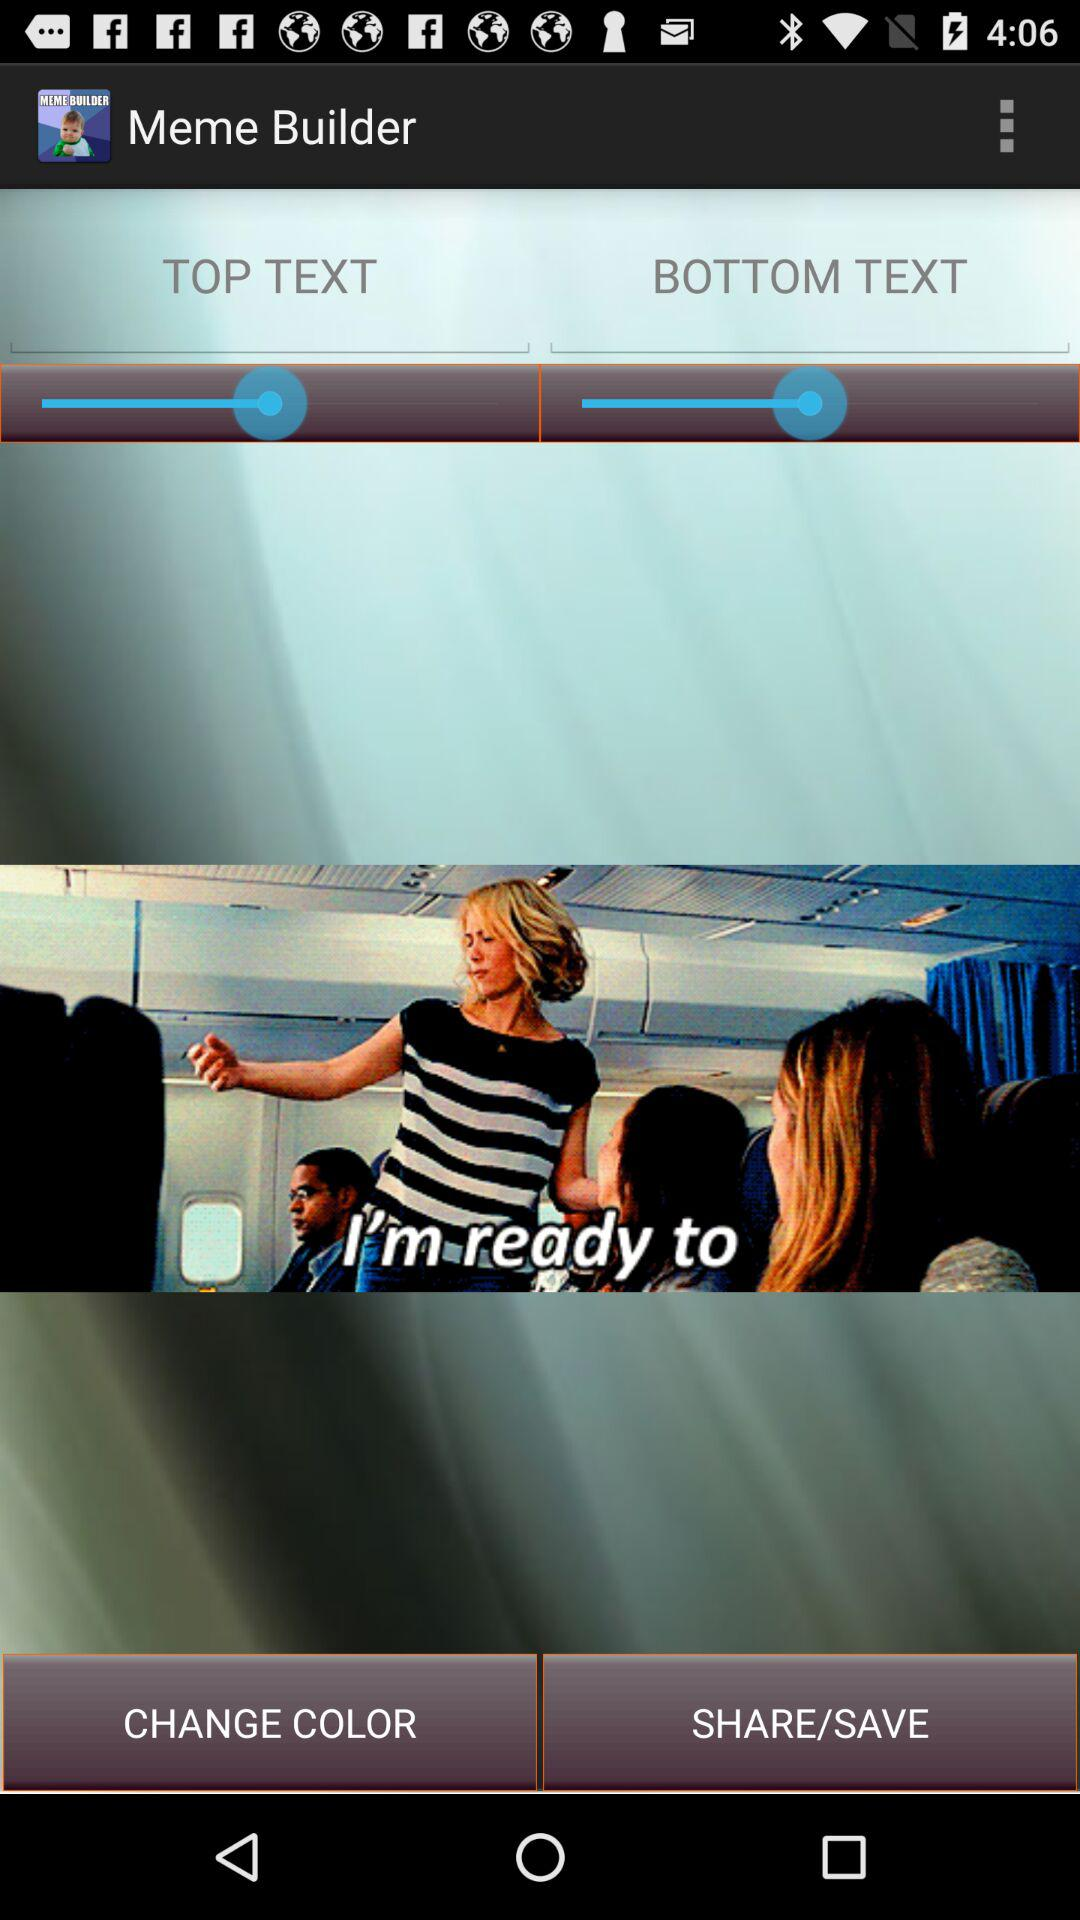What is the name of the application? The name of the application is "Meme Builder". 